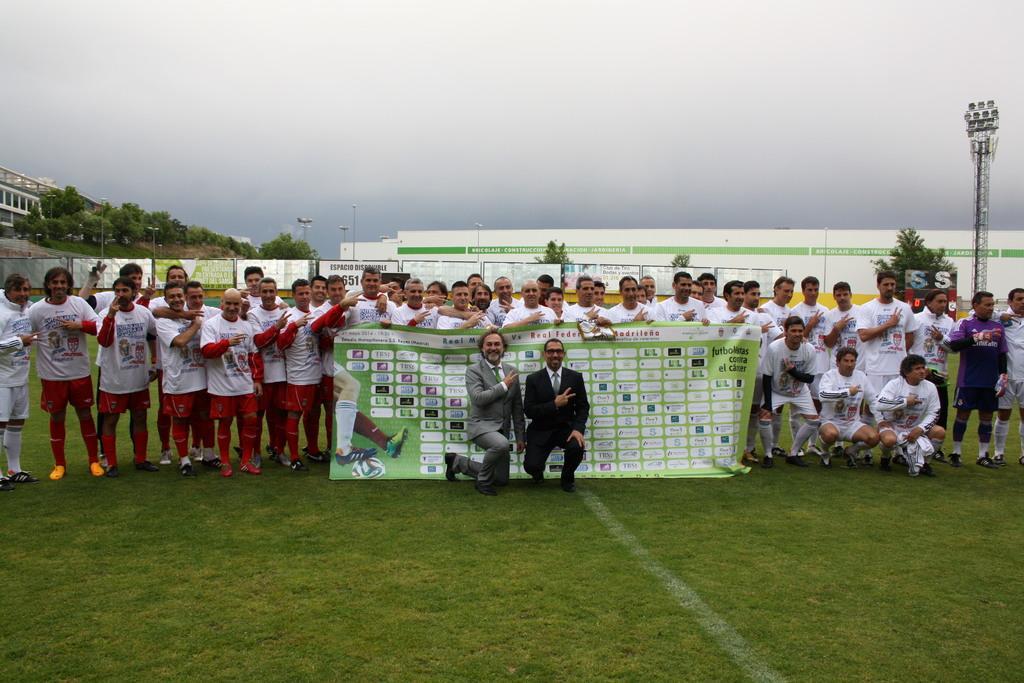Describe this image in one or two sentences. In the foreground of this image, there is the crowd standing and posing to the camera and few are squatting and few are kneeling down on the grass. We can also see few people holding a banner. In the background, there are poles, banners, boards, trees, buildings and the sky. 